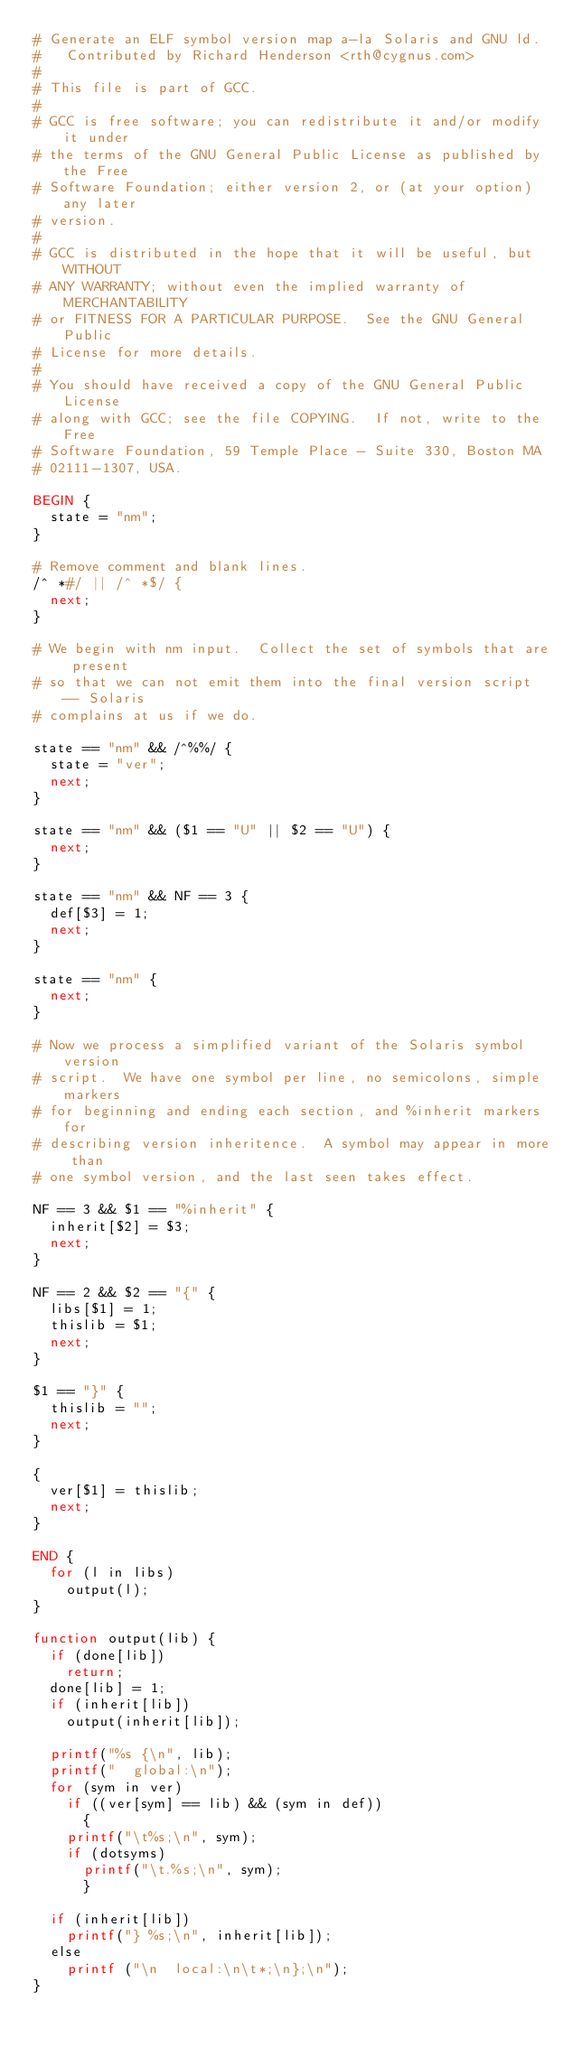<code> <loc_0><loc_0><loc_500><loc_500><_Awk_># Generate an ELF symbol version map a-la Solaris and GNU ld.
#	Contributed by Richard Henderson <rth@cygnus.com>
#
# This file is part of GCC.
#
# GCC is free software; you can redistribute it and/or modify it under
# the terms of the GNU General Public License as published by the Free
# Software Foundation; either version 2, or (at your option) any later
# version.
#
# GCC is distributed in the hope that it will be useful, but WITHOUT
# ANY WARRANTY; without even the implied warranty of MERCHANTABILITY
# or FITNESS FOR A PARTICULAR PURPOSE.  See the GNU General Public
# License for more details.
#
# You should have received a copy of the GNU General Public License
# along with GCC; see the file COPYING.  If not, write to the Free
# Software Foundation, 59 Temple Place - Suite 330, Boston MA
# 02111-1307, USA.

BEGIN {
  state = "nm";
}

# Remove comment and blank lines.
/^ *#/ || /^ *$/ {
  next;
}

# We begin with nm input.  Collect the set of symbols that are present
# so that we can not emit them into the final version script -- Solaris
# complains at us if we do.

state == "nm" && /^%%/ {
  state = "ver";
  next;
}

state == "nm" && ($1 == "U" || $2 == "U") {
  next;
}

state == "nm" && NF == 3 {
  def[$3] = 1;
  next;
}

state == "nm" {
  next;
}

# Now we process a simplified variant of the Solaris symbol version
# script.  We have one symbol per line, no semicolons, simple markers
# for beginning and ending each section, and %inherit markers for
# describing version inheritence.  A symbol may appear in more than
# one symbol version, and the last seen takes effect.

NF == 3 && $1 == "%inherit" {
  inherit[$2] = $3;
  next;
}

NF == 2 && $2 == "{" {
  libs[$1] = 1;
  thislib = $1;
  next;
}

$1 == "}" {
  thislib = "";
  next;
}

{
  ver[$1] = thislib;
  next;
}

END {
  for (l in libs)
    output(l);
}

function output(lib) {
  if (done[lib])
    return;
  done[lib] = 1;
  if (inherit[lib])
    output(inherit[lib]);

  printf("%s {\n", lib);
  printf("  global:\n");
  for (sym in ver)
    if ((ver[sym] == lib) && (sym in def))
      {
	printf("\t%s;\n", sym);
	if (dotsyms)
	  printf("\t.%s;\n", sym);
      }

  if (inherit[lib])
    printf("} %s;\n", inherit[lib]);
  else
    printf ("\n  local:\n\t*;\n};\n");
}
</code> 